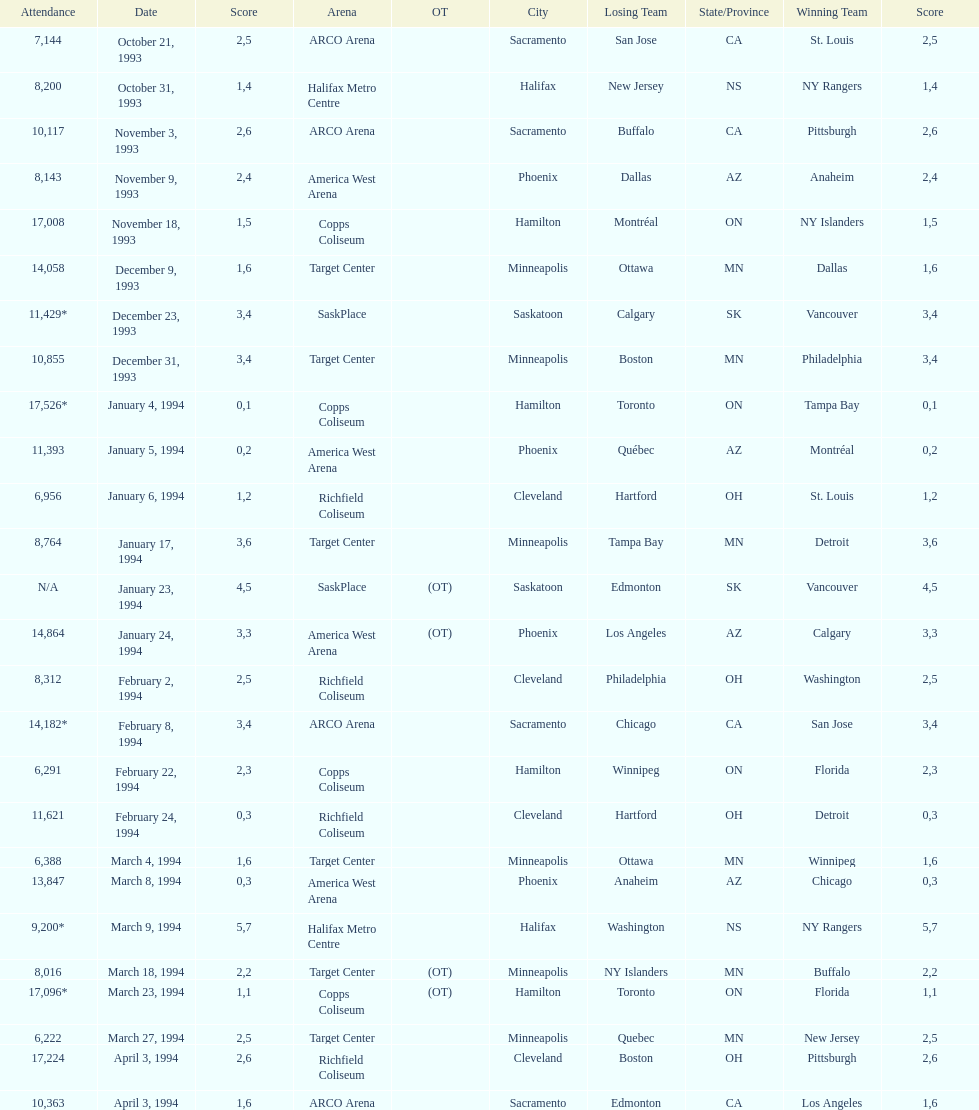Did dallas or ottawa win the december 9, 1993 game? Dallas. 